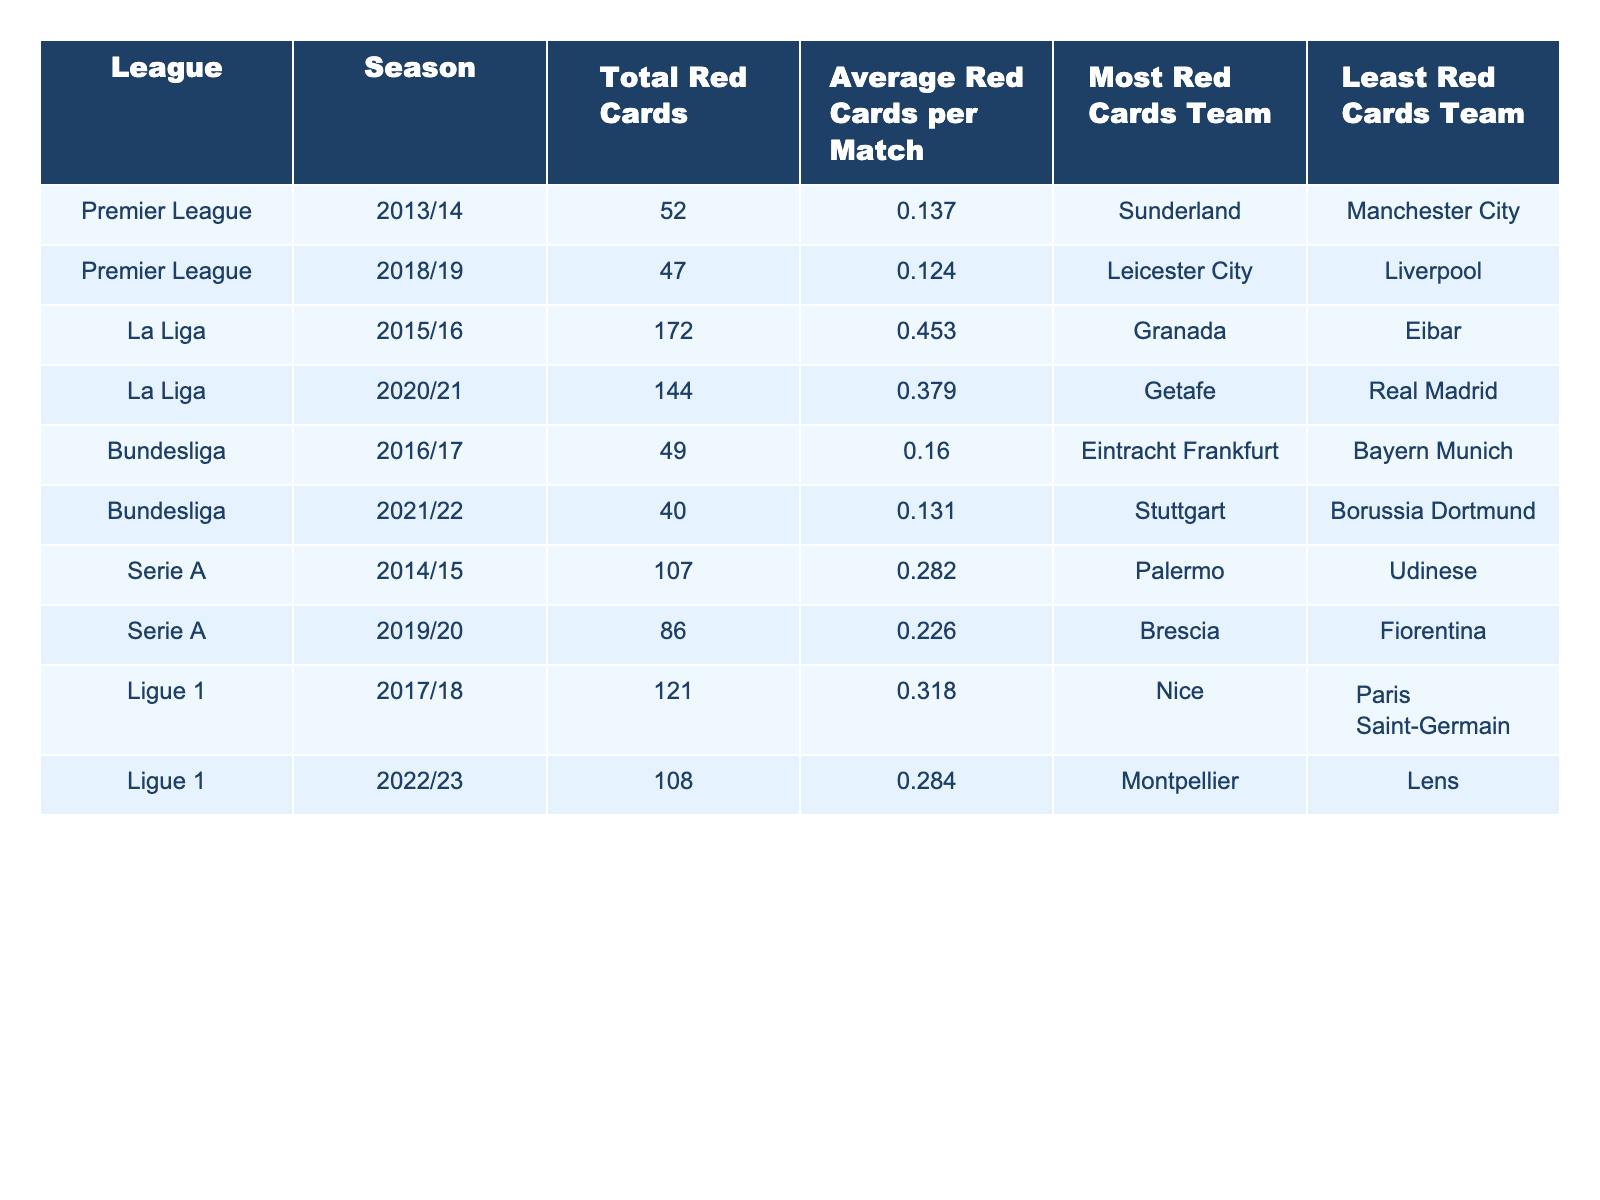What league had the highest total red cards in a single season? Looking at the table, La Liga in the 2015/16 season had the highest total red cards, which is 172.
Answer: La Liga, 2015/16 Which team received the least number of red cards in Serie A for the 2019/20 season? By checking the Serie A section of the table for the 2019/20 season, the team that received the least number of red cards was Fiorentina.
Answer: Fiorentina What is the average number of red cards per match in Ligue 1 for the 2022/23 season? For Ligue 1 in the 2022/23 season, the average number of red cards per match is listed as 0.284.
Answer: 0.284 In which league did the team with the most red cards, Granada, play? The team with the most red cards, Granada, played in La Liga according to the table entries.
Answer: La Liga What is the difference in average red cards per match between La Liga 2015/16 and Bundesliga 2016/17 seasons? The average for La Liga 2015/16 is 0.453, and for Bundesliga 2016/17, it is 0.160. The difference is 0.453 - 0.160 = 0.293.
Answer: 0.293 Which season had the highest average red cards per match across all leagues? By looking at the average red cards per match in all seasons, La Liga 2015/16 with an average of 0.453 is the highest.
Answer: La Liga 2015/16 True or False: The Premier League experienced more red cards in 2018/19 than the Bundesliga did in 2021/22. In Premier League 2018/19, there were 47 red cards, while in Bundesliga 2021/22, there were 40. Thus, it is true that Premier League had more red cards.
Answer: True Which league had a decreasing trend in average red cards from the 2017/18 to the 2022/23 seasons? In the table, Ligue 1 shows 0.318 average red cards in 2017/18 and decreases to 0.284 in 2022/23, indicating a decreasing trend.
Answer: Ligue 1 What is the combined total of red cards issued in Serie A for the seasons 2014/15 and 2019/20? From the table, Serie A had 107 red cards in 2014/15 and 86 in 2019/20. The combined total is 107 + 86 = 193.
Answer: 193 Which team in the Premier League had the most red cards during the 2013/14 season? According to the table, Sunderland had the most red cards in the Premier League during the 2013/14 season.
Answer: Sunderland 